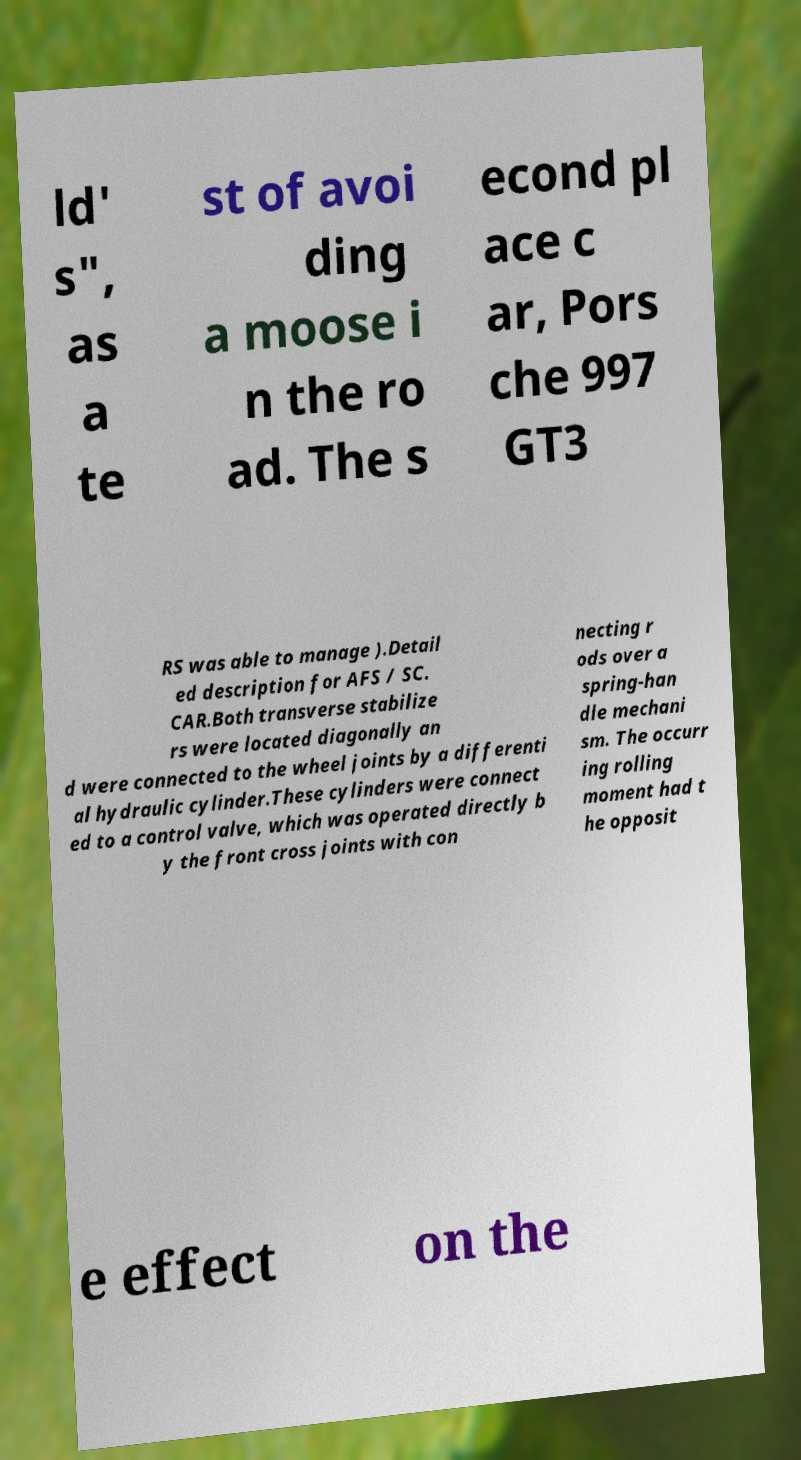For documentation purposes, I need the text within this image transcribed. Could you provide that? ld' s", as a te st of avoi ding a moose i n the ro ad. The s econd pl ace c ar, Pors che 997 GT3 RS was able to manage ).Detail ed description for AFS / SC. CAR.Both transverse stabilize rs were located diagonally an d were connected to the wheel joints by a differenti al hydraulic cylinder.These cylinders were connect ed to a control valve, which was operated directly b y the front cross joints with con necting r ods over a spring-han dle mechani sm. The occurr ing rolling moment had t he opposit e effect on the 